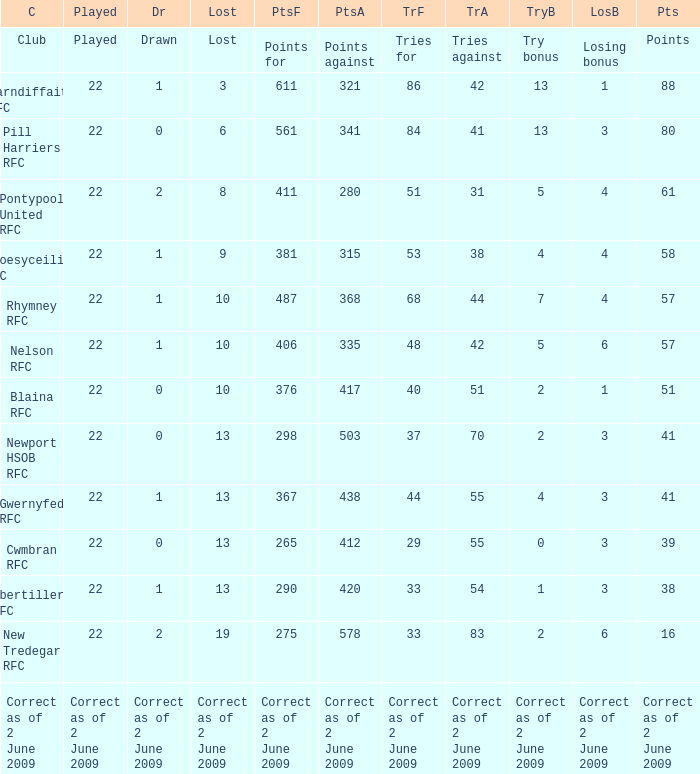How many tries did the club Croesyceiliog rfc have? 53.0. 